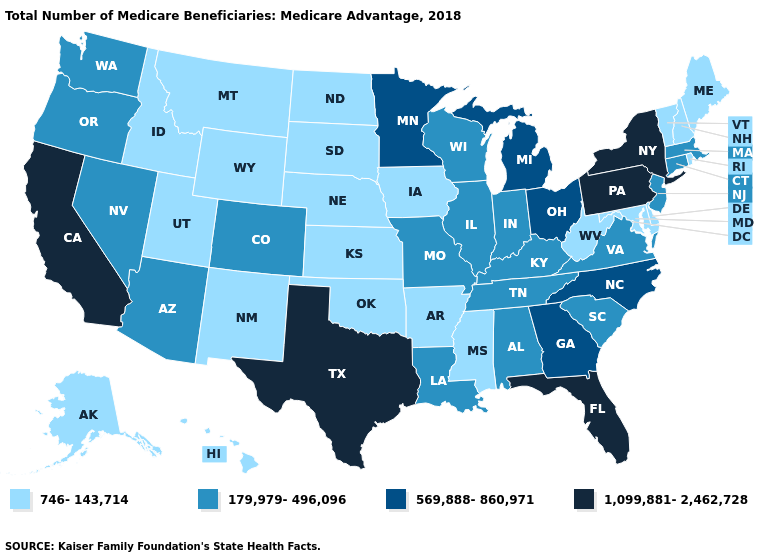What is the value of Maryland?
Concise answer only. 746-143,714. Among the states that border Kansas , does Colorado have the lowest value?
Concise answer only. No. What is the value of Colorado?
Short answer required. 179,979-496,096. Does Kansas have a higher value than North Carolina?
Concise answer only. No. What is the value of Maryland?
Quick response, please. 746-143,714. Name the states that have a value in the range 1,099,881-2,462,728?
Short answer required. California, Florida, New York, Pennsylvania, Texas. Does the map have missing data?
Keep it brief. No. Name the states that have a value in the range 746-143,714?
Concise answer only. Alaska, Arkansas, Delaware, Hawaii, Idaho, Iowa, Kansas, Maine, Maryland, Mississippi, Montana, Nebraska, New Hampshire, New Mexico, North Dakota, Oklahoma, Rhode Island, South Dakota, Utah, Vermont, West Virginia, Wyoming. What is the value of Alaska?
Answer briefly. 746-143,714. What is the lowest value in states that border Wisconsin?
Quick response, please. 746-143,714. Does New Mexico have the highest value in the USA?
Answer briefly. No. What is the value of Pennsylvania?
Short answer required. 1,099,881-2,462,728. What is the value of Nebraska?
Short answer required. 746-143,714. What is the value of Washington?
Be succinct. 179,979-496,096. Does Michigan have the lowest value in the USA?
Short answer required. No. 